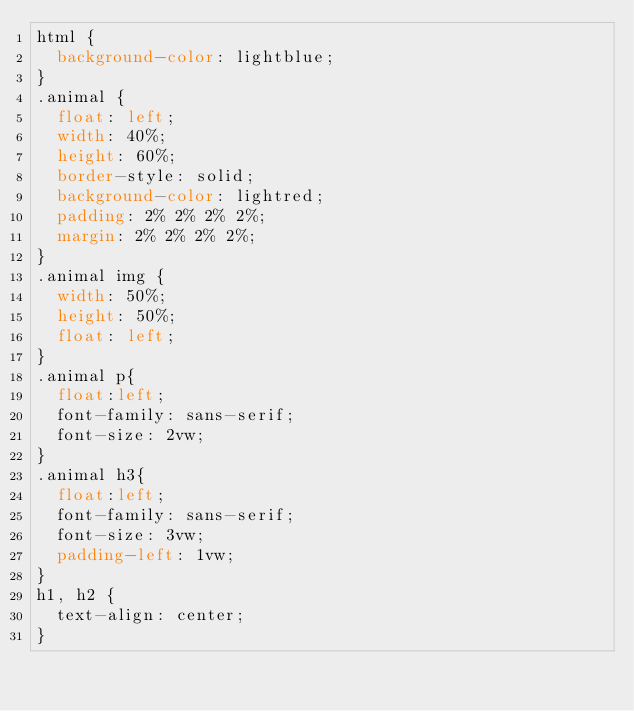Convert code to text. <code><loc_0><loc_0><loc_500><loc_500><_CSS_>html {
  background-color: lightblue;
}
.animal {
  float: left;
  width: 40%;
  height: 60%;
  border-style: solid;
  background-color: lightred;
  padding: 2% 2% 2% 2%;
  margin: 2% 2% 2% 2%;
}
.animal img {
  width: 50%;
  height: 50%;
  float: left;
}
.animal p{
  float:left;
  font-family: sans-serif;
  font-size: 2vw;
}
.animal h3{
  float:left;
  font-family: sans-serif;
  font-size: 3vw;
  padding-left: 1vw;
}
h1, h2 {
  text-align: center;
}
</code> 